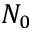Convert formula to latex. <formula><loc_0><loc_0><loc_500><loc_500>N _ { 0 }</formula> 